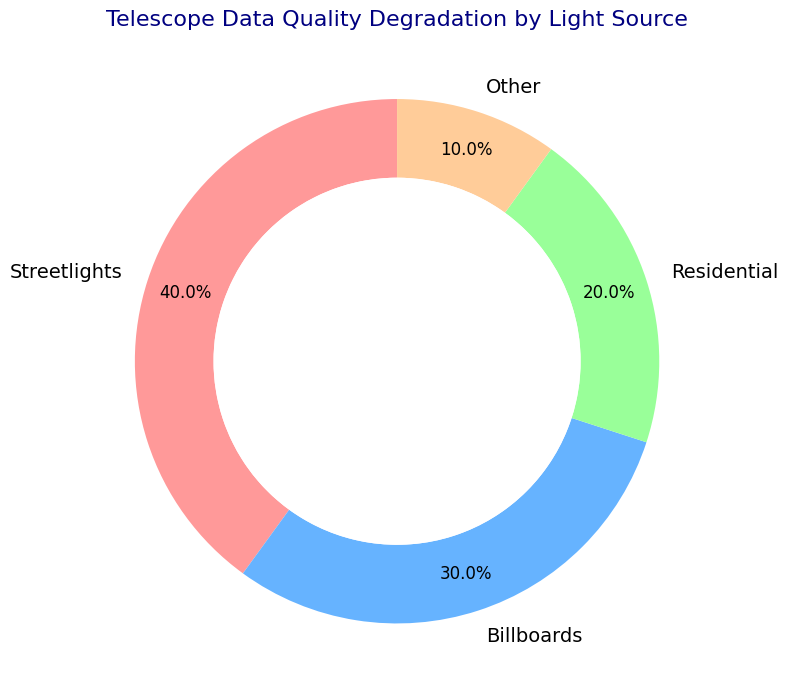What's the light source that contributes the most to telescope data quality degradation? By looking at the ring chart, it is clear that the largest segment, labeled with 40%, represents Streetlights. Therefore, we conclude that Streetlights contribute the most to the degradation.
Answer: Streetlights Which two light sources together account for more than half of the total degradation? Combining the percentages of Streetlights and Billboards (40% + 30%), we get 70%. Since 70% is more than 50%, these two sources together account for more than half of the total degradation.
Answer: Streetlights and Billboards How much more degradation do streetlights cause compared to residential sources? The ring chart shows that Streetlights account for 40% and Residential sources account for 20%. Subtracting these, 40% - 20% = 20%, so Streetlights cause 20% more degradation than Residential sources.
Answer: 20% What is the total percentage of degradation caused by sources other than streetlights? Summing the percentages of Billboards, Residential, and Other sources (30% + 20% + 10%), we get 60%.
Answer: 60% Which light source contributes the least to telescope data quality degradation? The smallest segment, labeled with 10%, represents the Other category. Therefore, the Other light source category contributes the least.
Answer: Other How do billboard and residential sources compare in their contributions to telescope data quality degradation? Billboards contribute 30% and Residential sources contribute 20%. Therefore, Billboards contribute 10% more than Residential sources.
Answer: Billboards contribute 10% more What is the combined degradation percentage from non-residential sources? Summing Streetlights, Billboards, and Other categories (40% + 30% + 10%), we get 80%.
Answer: 80% Which color in the ring chart corresponds to the residential sources? Residential sources are represented in green as indicated by the visual attribute associated with the percentage label in the ring chart.
Answer: Green 